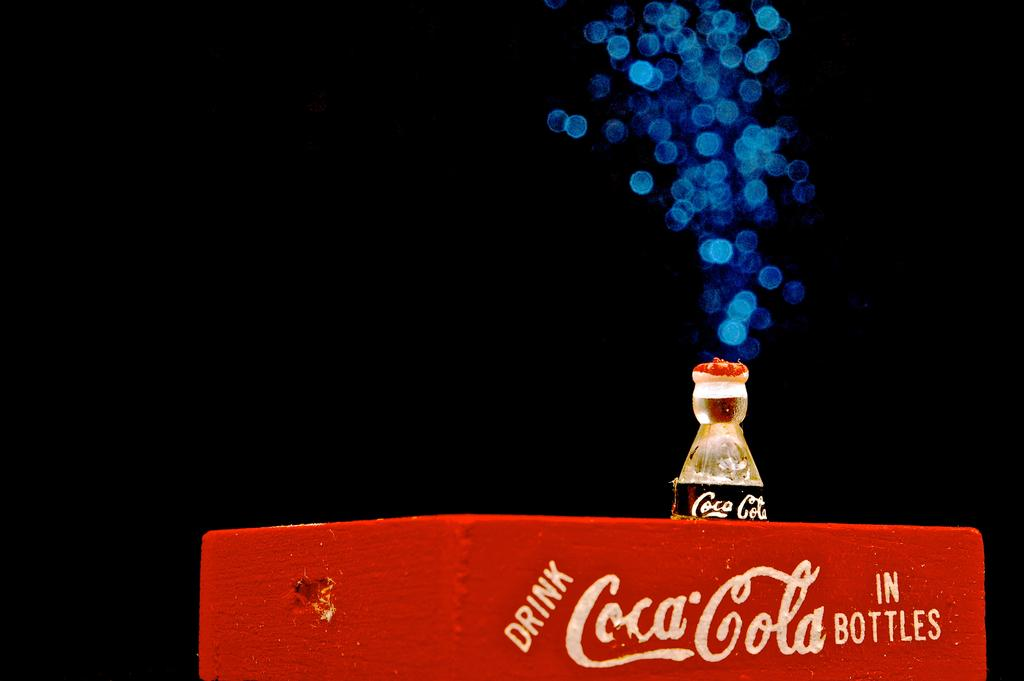What is the color of the box in the image? The box in the image is red. What else can be seen in the image besides the red box? There is a cool drink bottle in the image. Is there a book on the table next to the red box in the image? There is no mention of a table or a book in the image, so we cannot confirm their presence. 